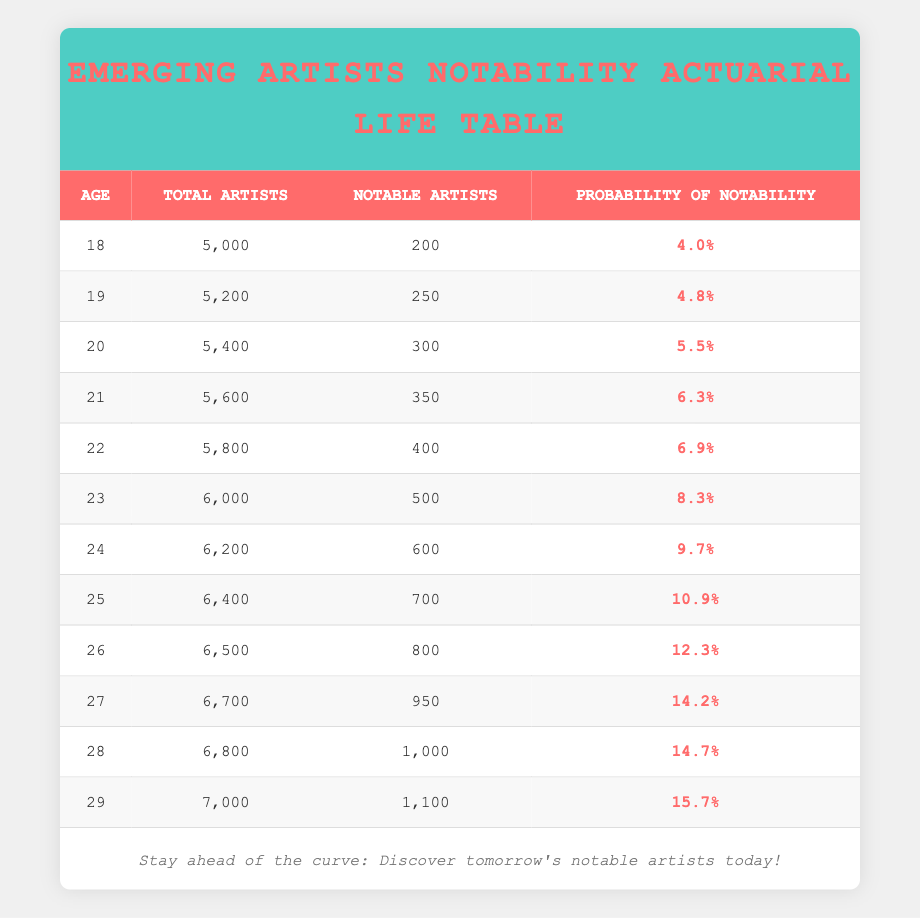What is the total number of artists at age 21? From the table, the "Total Artists" for age 21 is listed directly as 5600.
Answer: 5600 What is the probability of notability for artists aged 25? Looking at the table, the "Probability of Notability" for age 25 is shown as 0.109 or 10.9 percent.
Answer: 10.9% How many notable artists are there at age 22 compared to age 18? The number of notable artists at age 22 is 400 and at age 18 is 200. The difference is 400 - 200 = 200.
Answer: 200 Is the probability of notability highest for artists aged 29? The table shows the probabilities; at age 29, the probability is 0.157 or 15.7 percent, which is indeed the highest among all age groups listed.
Answer: Yes What is the average number of notable artists from ages 18 to 24? Adding the notable artists from 18 to 24 gives us: 200 + 250 + 300 + 350 + 400 + 500 + 600 = 2600. There are 7 data points, so the average is 2600 / 7 ≈ 371.43, rounded to 371.
Answer: 371 Which age group has the lowest probability of notability? The probabilities show that at age 18, the probability of notability is the lowest at 0.04 or 4.0%.
Answer: Age 18 How many total artists are there from ages 26 to 29 combined? The total artists from ages 26 to 29 are: 6500 (age 26) + 6700 (age 27) + 6800 (age 28) + 7000 (age 29) = 26700.
Answer: 26700 Is the probability of notability for age 24 greater than 0.1? The table states that the probability of notability for age 24 is 0.097 or 9.7%, which is less than 0.1.
Answer: No 